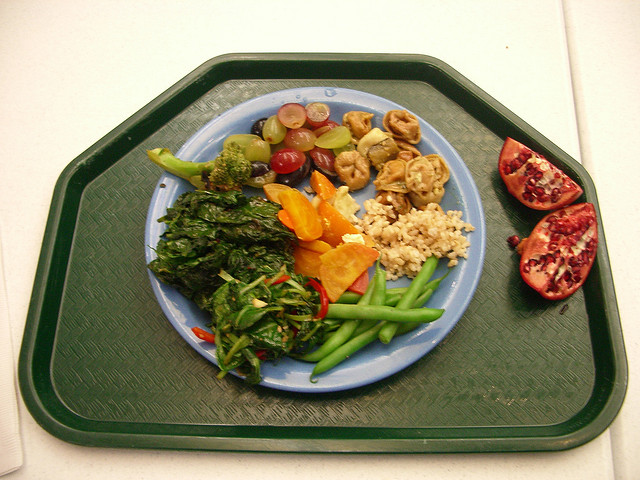<image>What food is on lower left? It is uncertain what kind of food is in the lower left. It could be spinach, beans, kale, broccoli, or other greens. What food is on lower left? I am not sure what food is on the lower left. It can be seen as spinach, beans, kale, broccoli, or greens. 